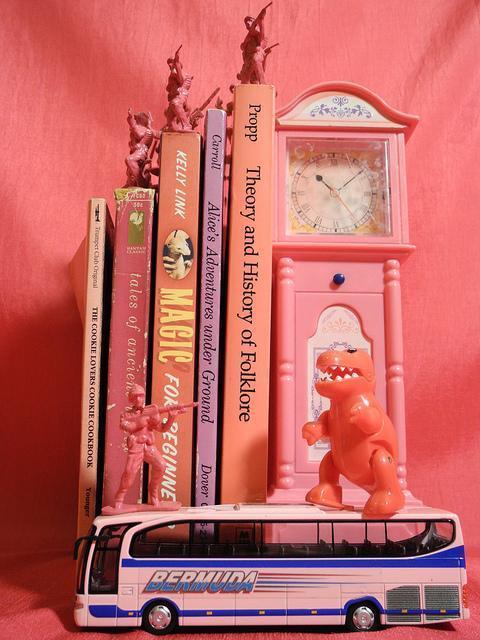How many cows are seen?
Give a very brief answer. 0. 